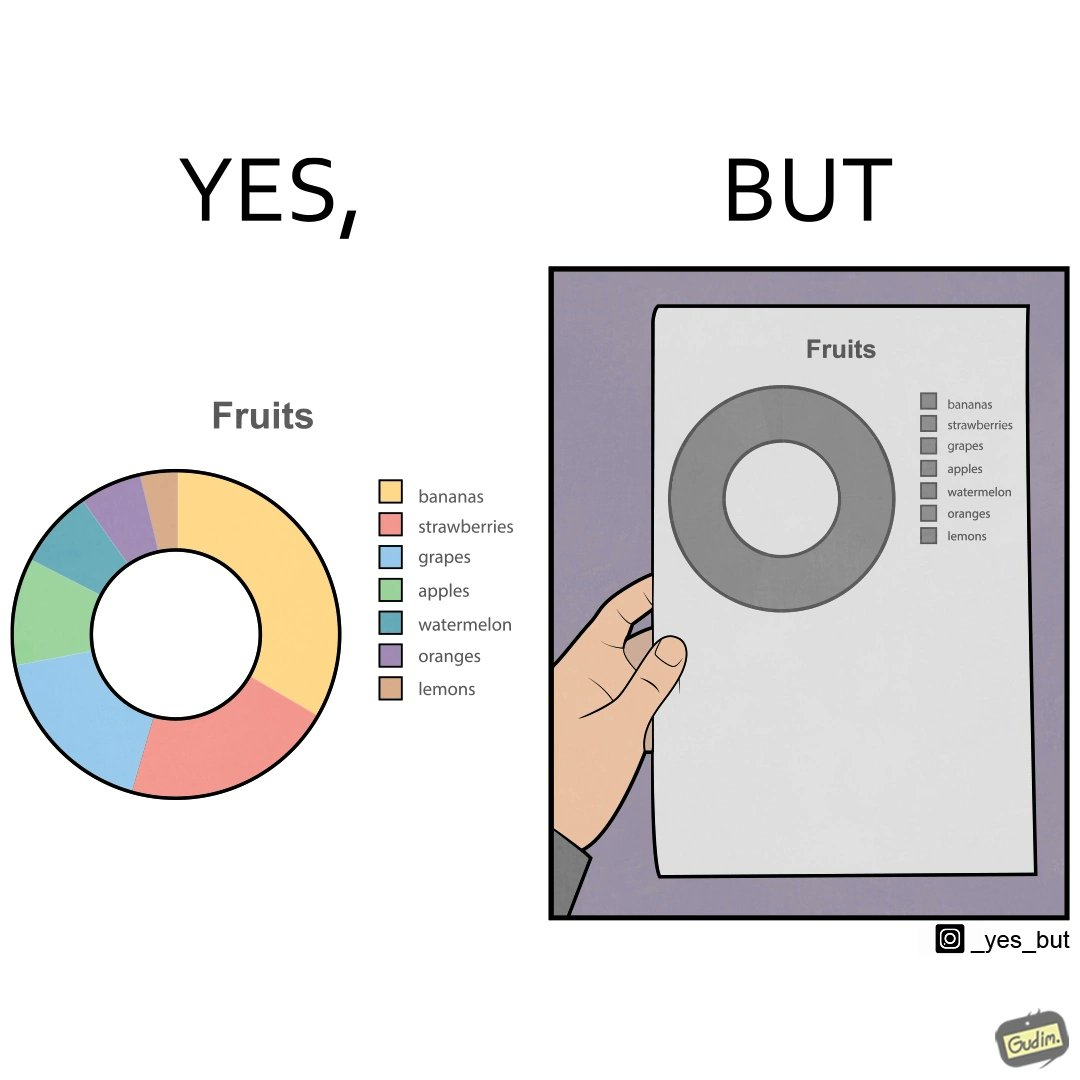What is shown in this image? This is funny because the pie chart printout is useless as you cant see any divisions on it because the  printer could not capture the different colors 